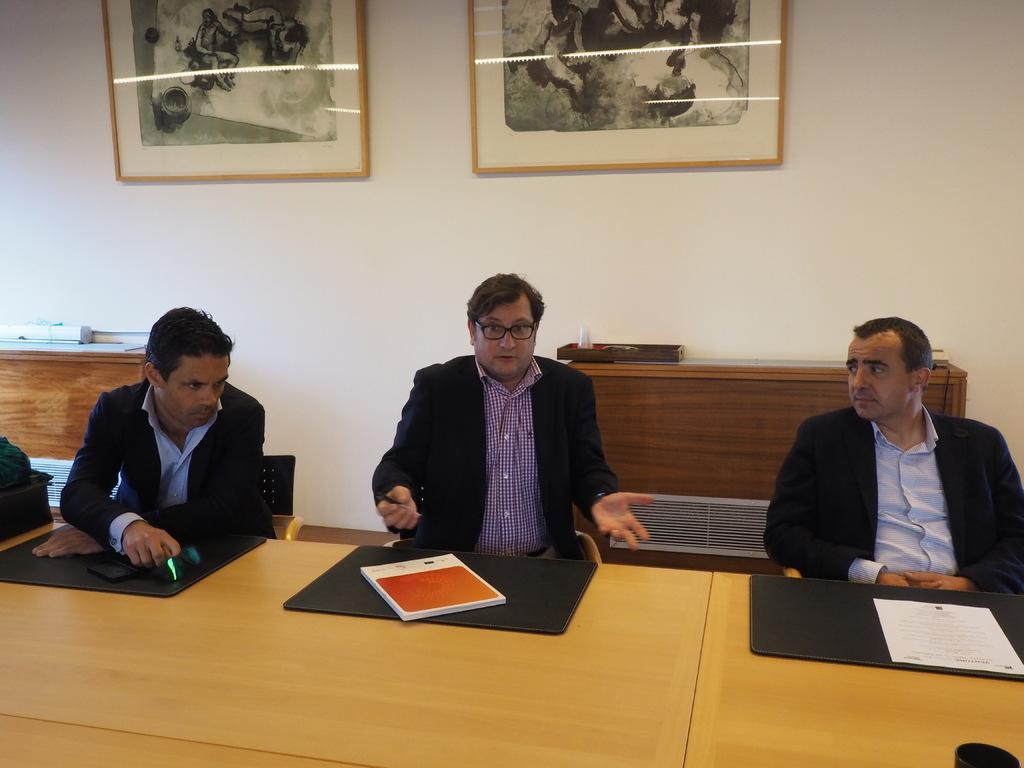Can you describe this image briefly? Here in this picture we can see three men sitting on chairs and we can see all of them are wearing black colored coats and in front of them we can see a table, on which we can see books and papers present, the person in the middle is wearing spectacles and speaking something and behind them we can see tables present with something present on it and on the wall we can see portraits present. 